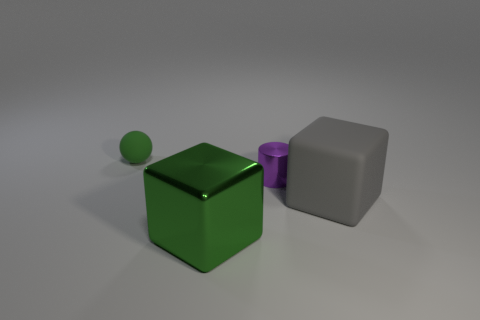Add 3 blue metallic blocks. How many objects exist? 7 Subtract all cylinders. How many objects are left? 3 Subtract all green rubber objects. Subtract all small green balls. How many objects are left? 2 Add 2 small metal cylinders. How many small metal cylinders are left? 3 Add 4 tiny yellow rubber cylinders. How many tiny yellow rubber cylinders exist? 4 Subtract 0 brown cylinders. How many objects are left? 4 